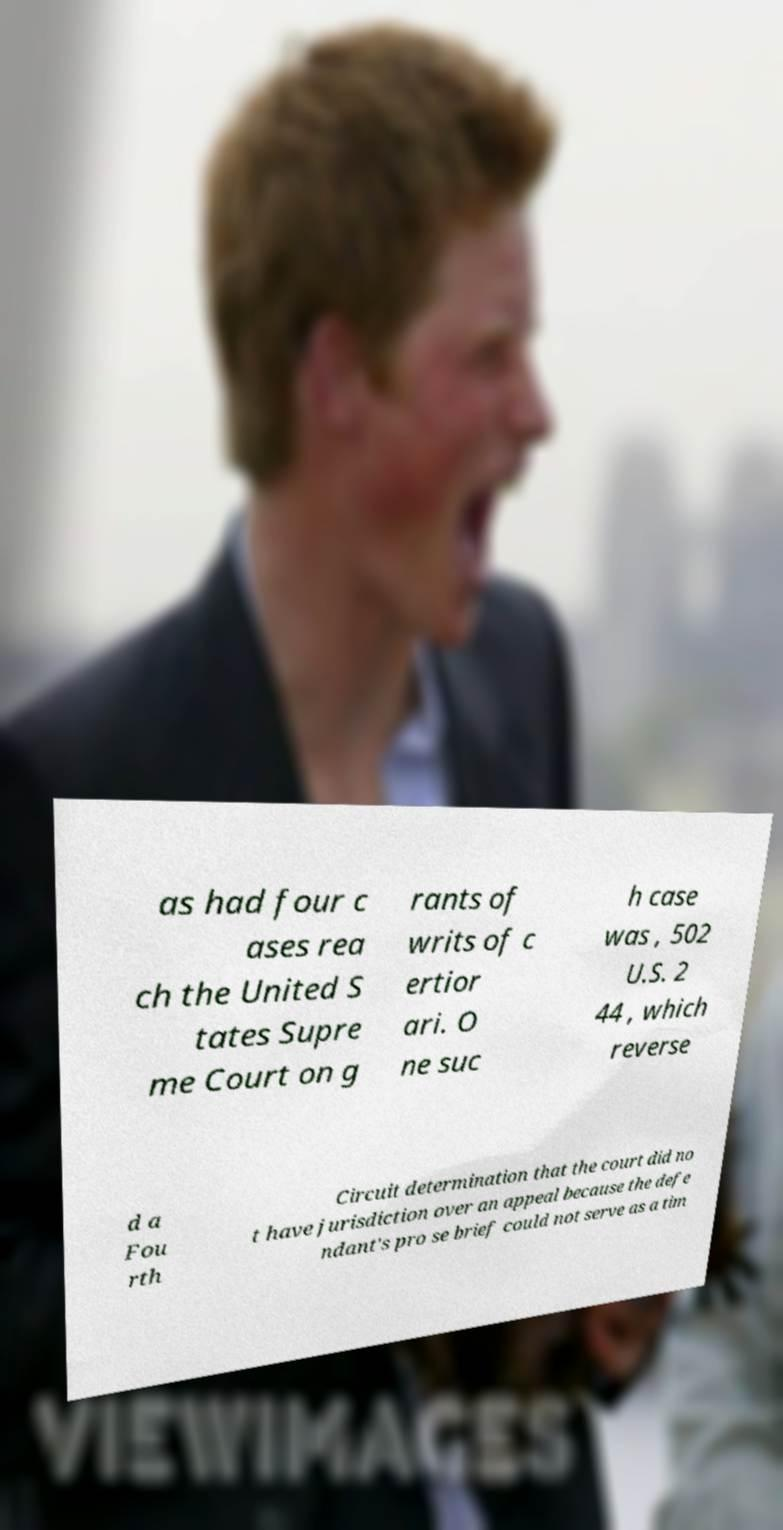There's text embedded in this image that I need extracted. Can you transcribe it verbatim? as had four c ases rea ch the United S tates Supre me Court on g rants of writs of c ertior ari. O ne suc h case was , 502 U.S. 2 44 , which reverse d a Fou rth Circuit determination that the court did no t have jurisdiction over an appeal because the defe ndant's pro se brief could not serve as a tim 